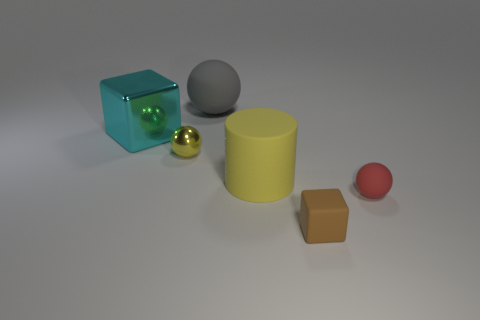Subtract 1 balls. How many balls are left? 2 Subtract all big rubber spheres. How many spheres are left? 2 Add 4 large gray metal balls. How many objects exist? 10 Subtract 0 gray cubes. How many objects are left? 6 Subtract all blocks. How many objects are left? 4 Subtract all balls. Subtract all cyan blocks. How many objects are left? 2 Add 1 small red balls. How many small red balls are left? 2 Add 2 small purple metallic spheres. How many small purple metallic spheres exist? 2 